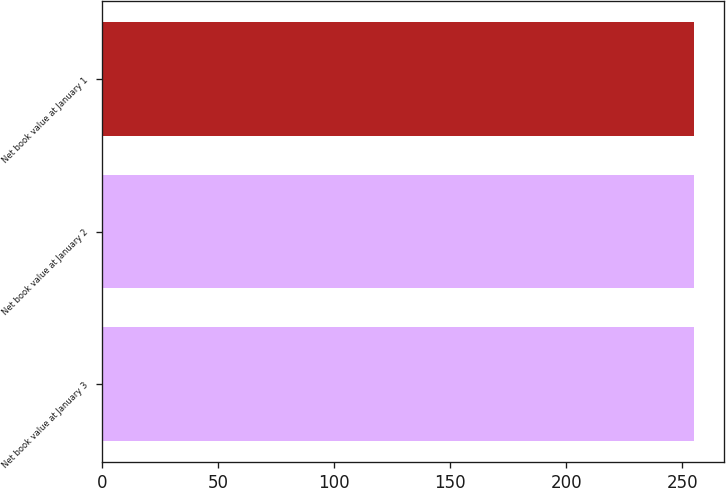<chart> <loc_0><loc_0><loc_500><loc_500><bar_chart><fcel>Net book value at January 3<fcel>Net book value at January 2<fcel>Net book value at January 1<nl><fcel>255<fcel>255.1<fcel>255.2<nl></chart> 